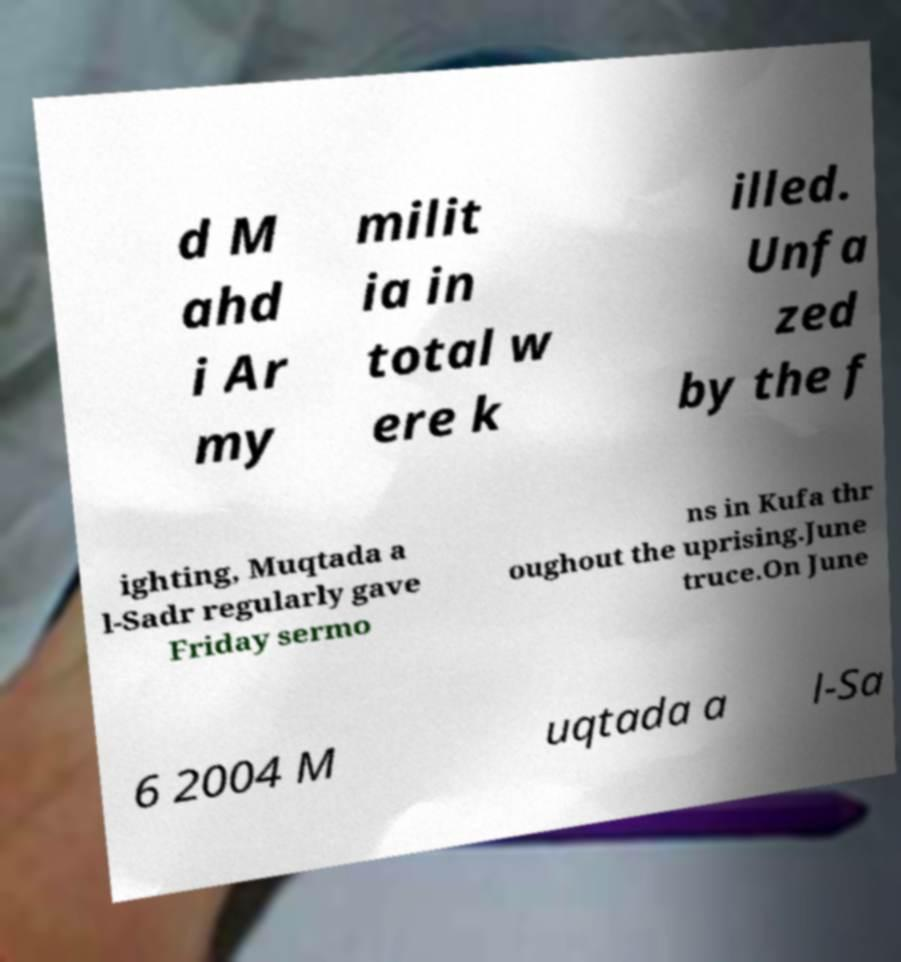Please identify and transcribe the text found in this image. d M ahd i Ar my milit ia in total w ere k illed. Unfa zed by the f ighting, Muqtada a l-Sadr regularly gave Friday sermo ns in Kufa thr oughout the uprising.June truce.On June 6 2004 M uqtada a l-Sa 